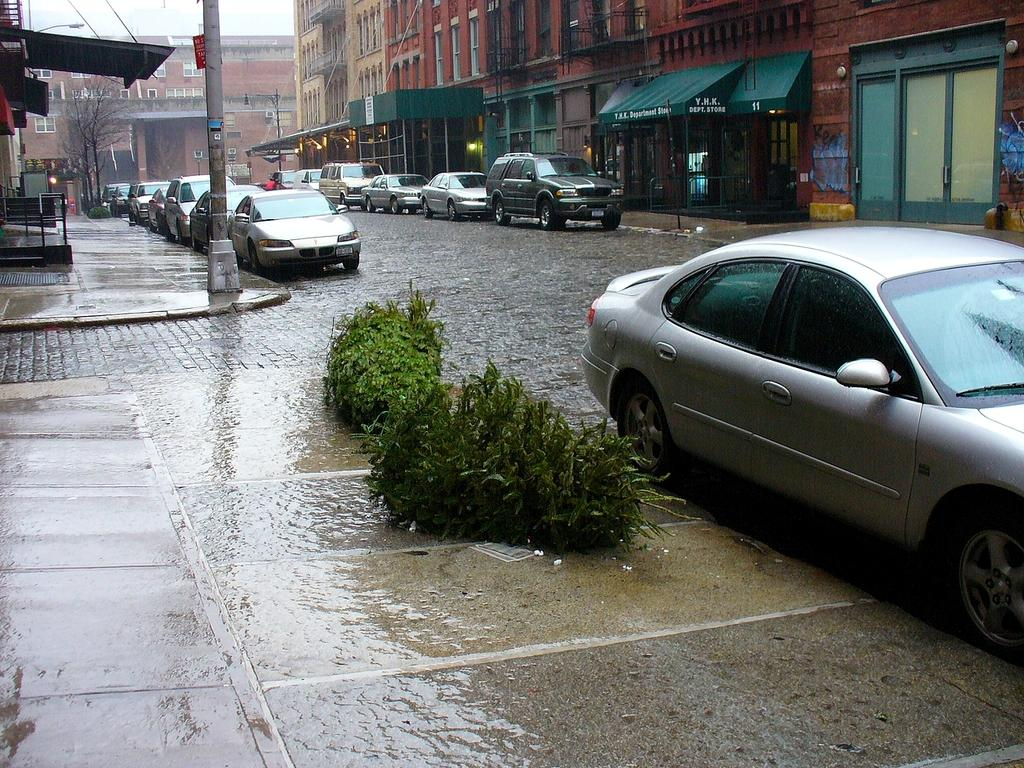What can be seen on the road in the image? There are vehicles parked on the road in the image. What else is visible in the image besides the parked vehicles? There are buildings, plants, trees, and the sky visible in the image. What type of beast can be seen interacting with the plants in the image? There is no beast present in the image; it features vehicles, buildings, plants, trees, and the sky. How many ducks are visible in the image? There are no ducks present in the image. 